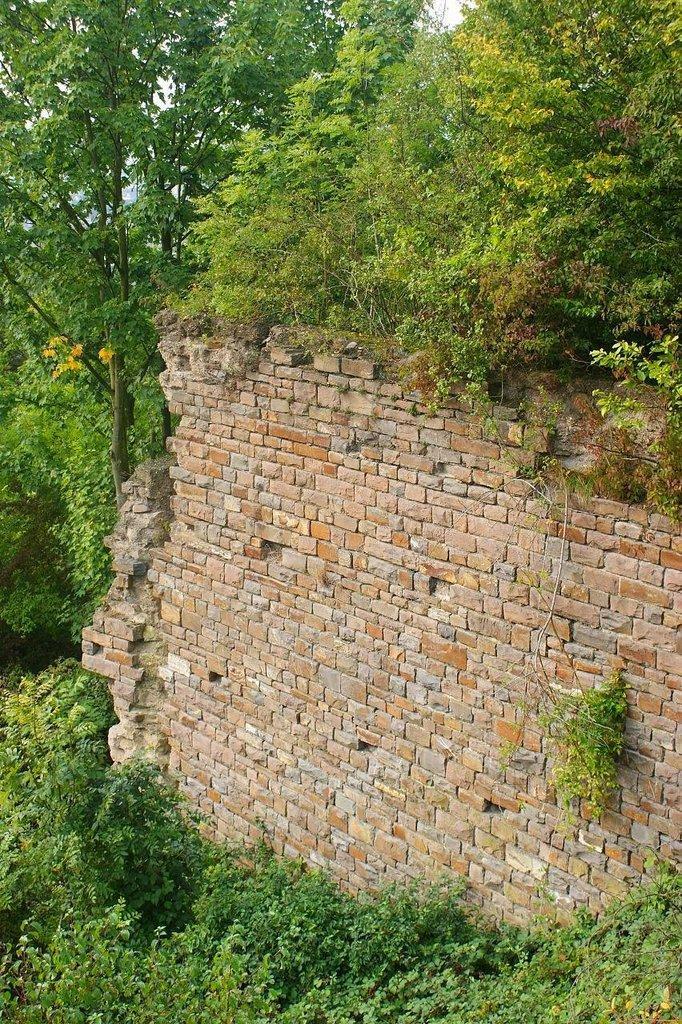Please provide a concise description of this image. In this image there is a brick wall in the middle. There are plants around the wall. 